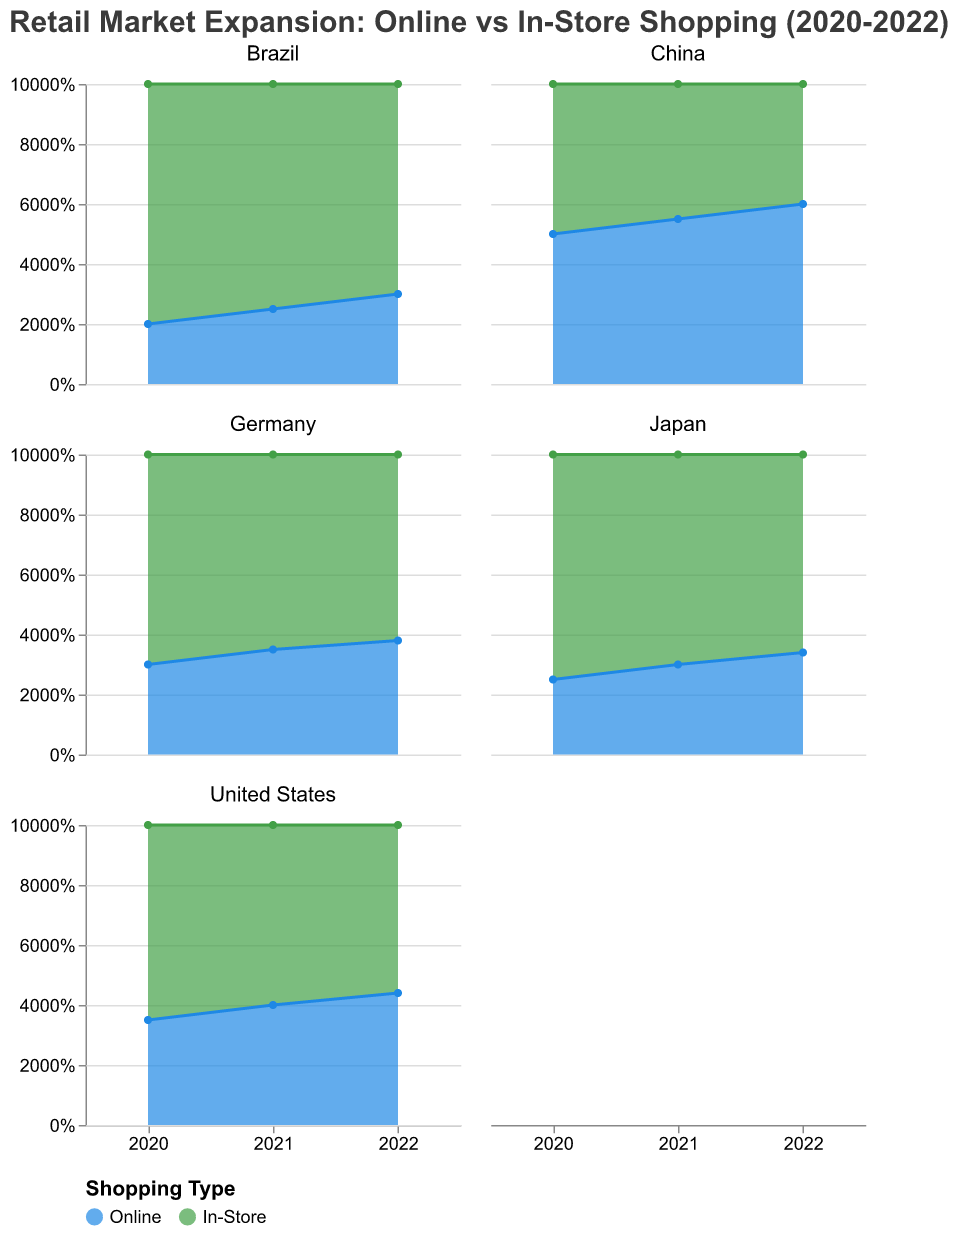Which country showed the highest percentage of online shopping in 2022? From the figure, look for the 2022 data points across all countries and compare the percentages for online shopping. China shows the highest percentage of online shopping at 60%.
Answer: China What was the trend for in-store shopping in the United States from 2020 to 2022? From the United States subplot, observe the percentage of in-store shopping for each year from 2020 to 2022. The percentage decreased from 65% (2020) to 60% (2021) and then to 56% (2022).
Answer: Decreasing Compare the percentage of online shopping in Japan and Germany in 2021. Which country had a higher percentage? Locate the 2021 data points for online shopping in both Japan and Germany. Germany had 35% while Japan had 30%, making Germany higher.
Answer: Germany What was the approximate difference in the percentage of online shopping between Brazil and China in 2020? From the subplots, identify the 2020 online shopping percentages for Brazil and China. Brazil had 20%, and China had 50%. The difference is 50% - 20% = 30%.
Answer: 30% Identify the country with the smallest growth in online shopping from 2020 to 2022. Calculate the growth for each country by subtracting the 2020 percentage from the 2022 percentage. Brazil's growth is the smallest, from 20% to 30%, a difference of 10%.
Answer: Brazil How did the online shopping percentage in Germany change between 2020 and 2022? Refer to Germany's subplot and find the online shopping percentages for 2020 and 2022. The percentage increased from 30% to 38%.
Answer: Increased What percentage of shopping was done in-store in Japan in 2022? Check Japan's subplot for the in-store shopping percentage in 2022, which is 66%.
Answer: 66% In which year did the percentage of online shopping in China surpass the percentage of in-store shopping? Examine China's subplot for the years when online shopping percentage exceeded in-store shopping. This occurred in 2021 when online was 55% and in-store was 45%.
Answer: 2021 Which country had the highest preference for in-store shopping in 2020? Look at the 2020 in-store shopping percentages across all countries. Brazil had the highest preference at 80%.
Answer: Brazil 